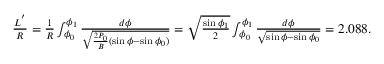<formula> <loc_0><loc_0><loc_500><loc_500>\begin{array} { r } { \frac { L ^ { ^ { \prime } } } { R } = \frac { 1 } { R } \int _ { \phi _ { 0 } } ^ { \phi _ { 1 } } \frac { d \phi } { \sqrt { \frac { 2 P _ { 0 } } { B } ( \sin \phi - \sin \phi _ { 0 } ) } } = \sqrt { \frac { \sin \phi _ { 1 } } { 2 } } \int _ { \phi _ { 0 } } ^ { \phi _ { 1 } } \frac { d \phi } { \sqrt { \sin \phi - \sin \phi _ { 0 } } } = 2 . 0 8 8 . } \end{array}</formula> 